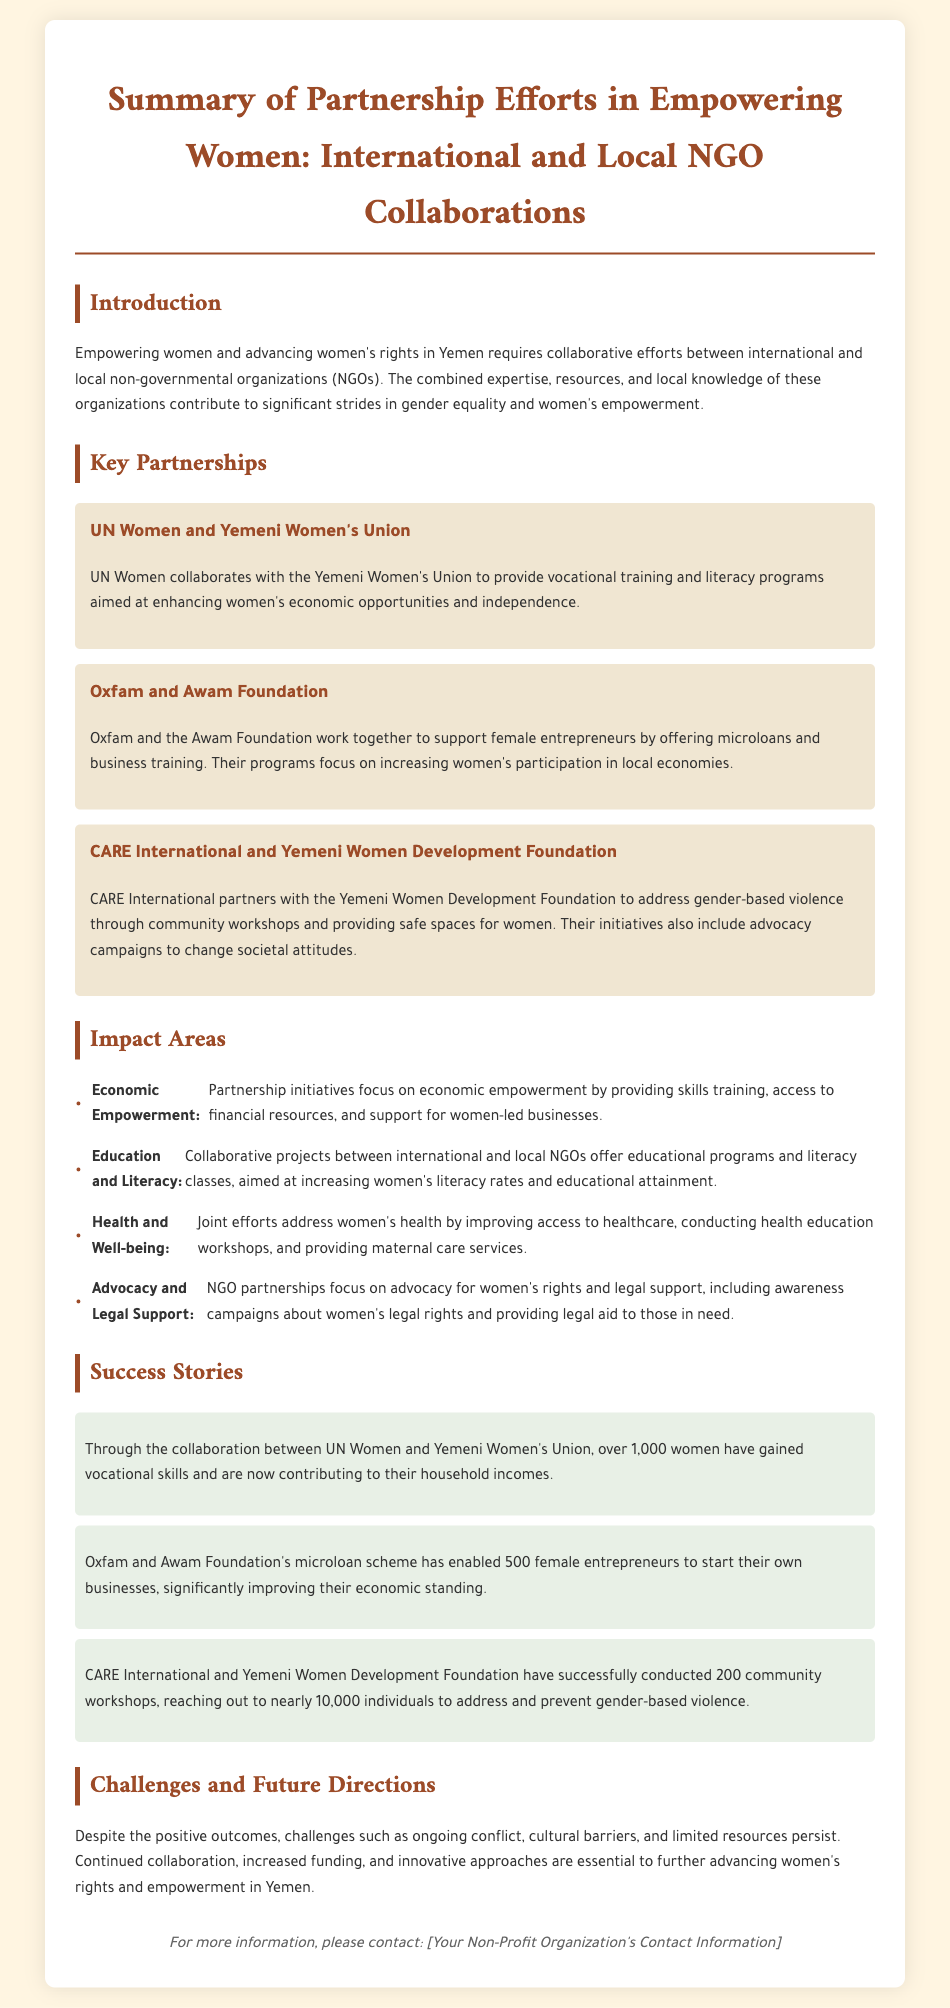What is the main purpose of the document? The document summarizes partnership efforts in empowering women through collaborative initiatives between NGOs.
Answer: Empowering women Which international NGO is partnered with the Yemeni Women's Union? UN Women collaborates with the Yemeni Women's Union for vocational training and literacy programs.
Answer: UN Women How many women gained vocational skills through the UN Women partnership? Over 1,000 women gained vocational skills through the collaboration with the Yemeni Women's Union.
Answer: 1,000 What does Oxfam and Awam Foundation support? They support female entrepreneurs by offering microloans and business training.
Answer: Microloans and business training How many female entrepreneurs benefited from Oxfam's microloan scheme? The microloan scheme has enabled 500 female entrepreneurs to start their businesses.
Answer: 500 Which area do CARE International and the Yemeni Women Development Foundation address? They address gender-based violence through community workshops and advocacy campaigns.
Answer: Gender-based violence What is one of the challenges mentioned in the document? Ongoing conflict is one of the challenges faced in advancing women's rights.
Answer: Ongoing conflict What type of programs does the document highlight for women's empowerment? The document highlights vocational training, literacy programs, and advocacy campaigns.
Answer: Vocational training, literacy programs, and advocacy campaigns 